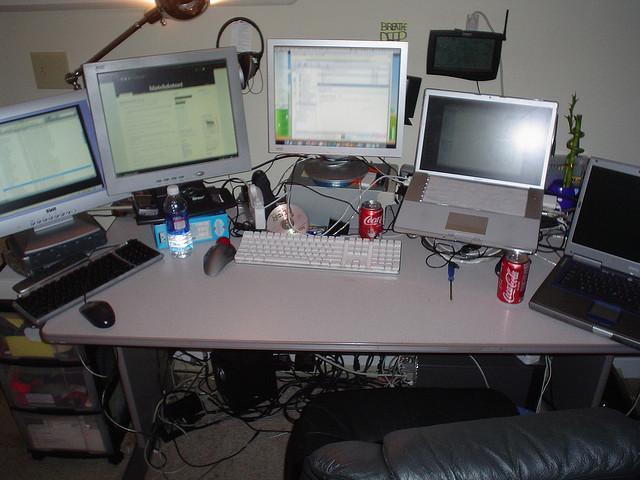How many drinks are on the desk?
Give a very brief answer. 3. How many tvs can be seen?
Give a very brief answer. 3. How many keyboards can be seen?
Give a very brief answer. 2. How many laptops can you see?
Give a very brief answer. 2. 